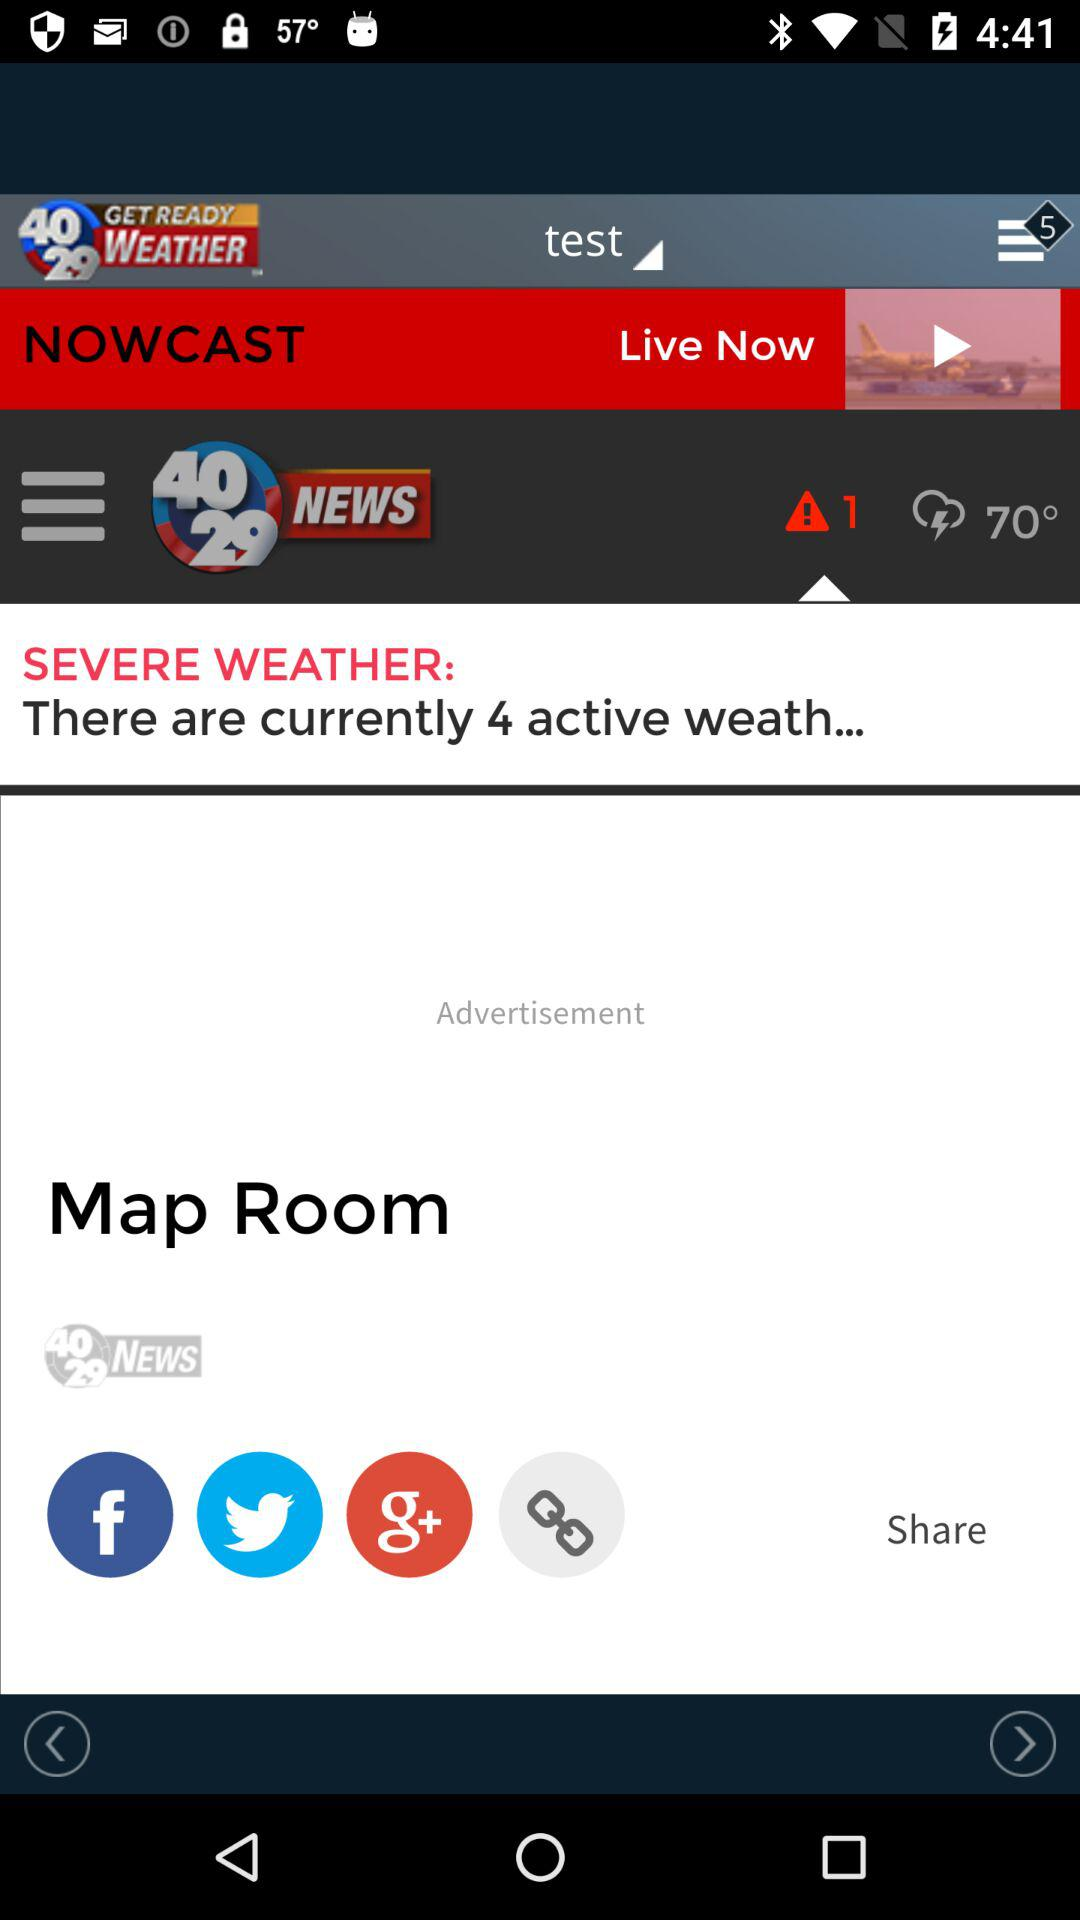What are the content sharing applications? The sharing applications are "Facebook", "Twitter", and "Google+". 